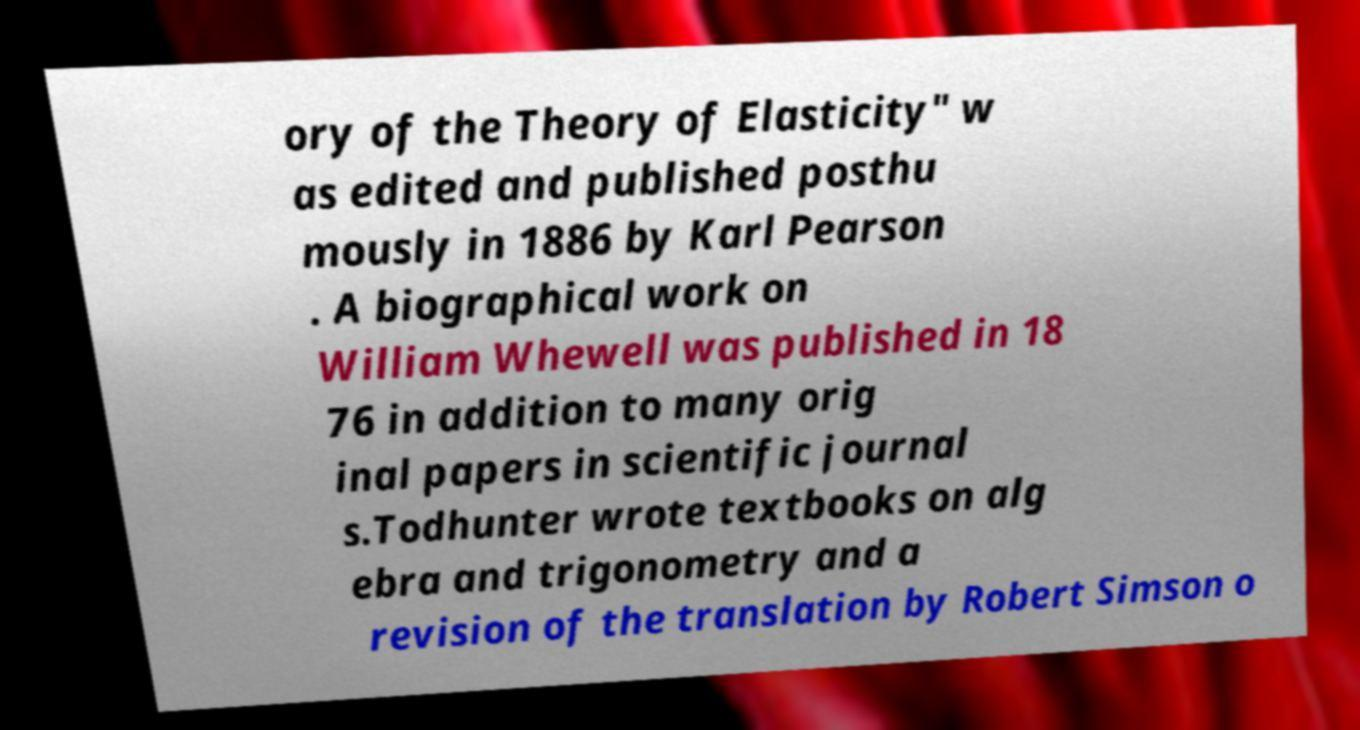There's text embedded in this image that I need extracted. Can you transcribe it verbatim? ory of the Theory of Elasticity" w as edited and published posthu mously in 1886 by Karl Pearson . A biographical work on William Whewell was published in 18 76 in addition to many orig inal papers in scientific journal s.Todhunter wrote textbooks on alg ebra and trigonometry and a revision of the translation by Robert Simson o 